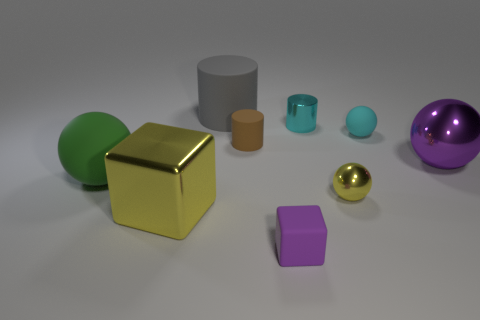Subtract all cylinders. How many objects are left? 6 Subtract all large yellow metal blocks. Subtract all metallic things. How many objects are left? 4 Add 3 big blocks. How many big blocks are left? 4 Add 9 blue spheres. How many blue spheres exist? 9 Subtract 0 gray balls. How many objects are left? 9 